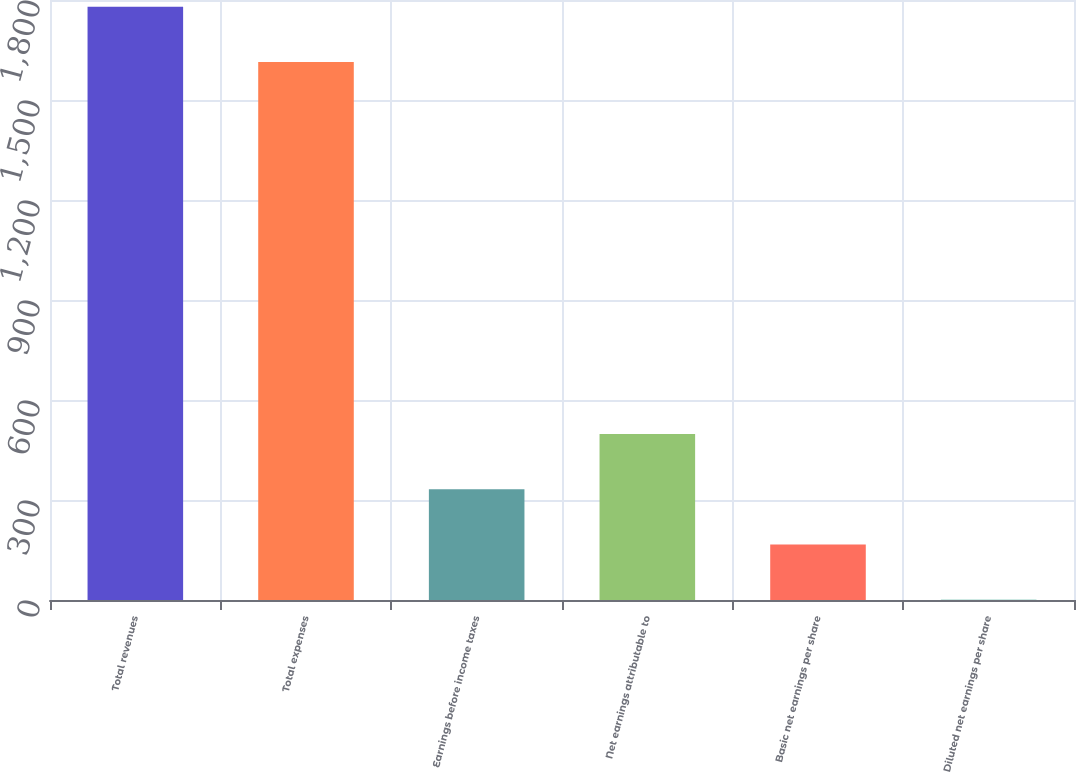<chart> <loc_0><loc_0><loc_500><loc_500><bar_chart><fcel>Total revenues<fcel>Total expenses<fcel>Earnings before income taxes<fcel>Net earnings attributable to<fcel>Basic net earnings per share<fcel>Diluted net earnings per share<nl><fcel>1779.88<fcel>1614.2<fcel>331.99<fcel>497.67<fcel>166.31<fcel>0.63<nl></chart> 